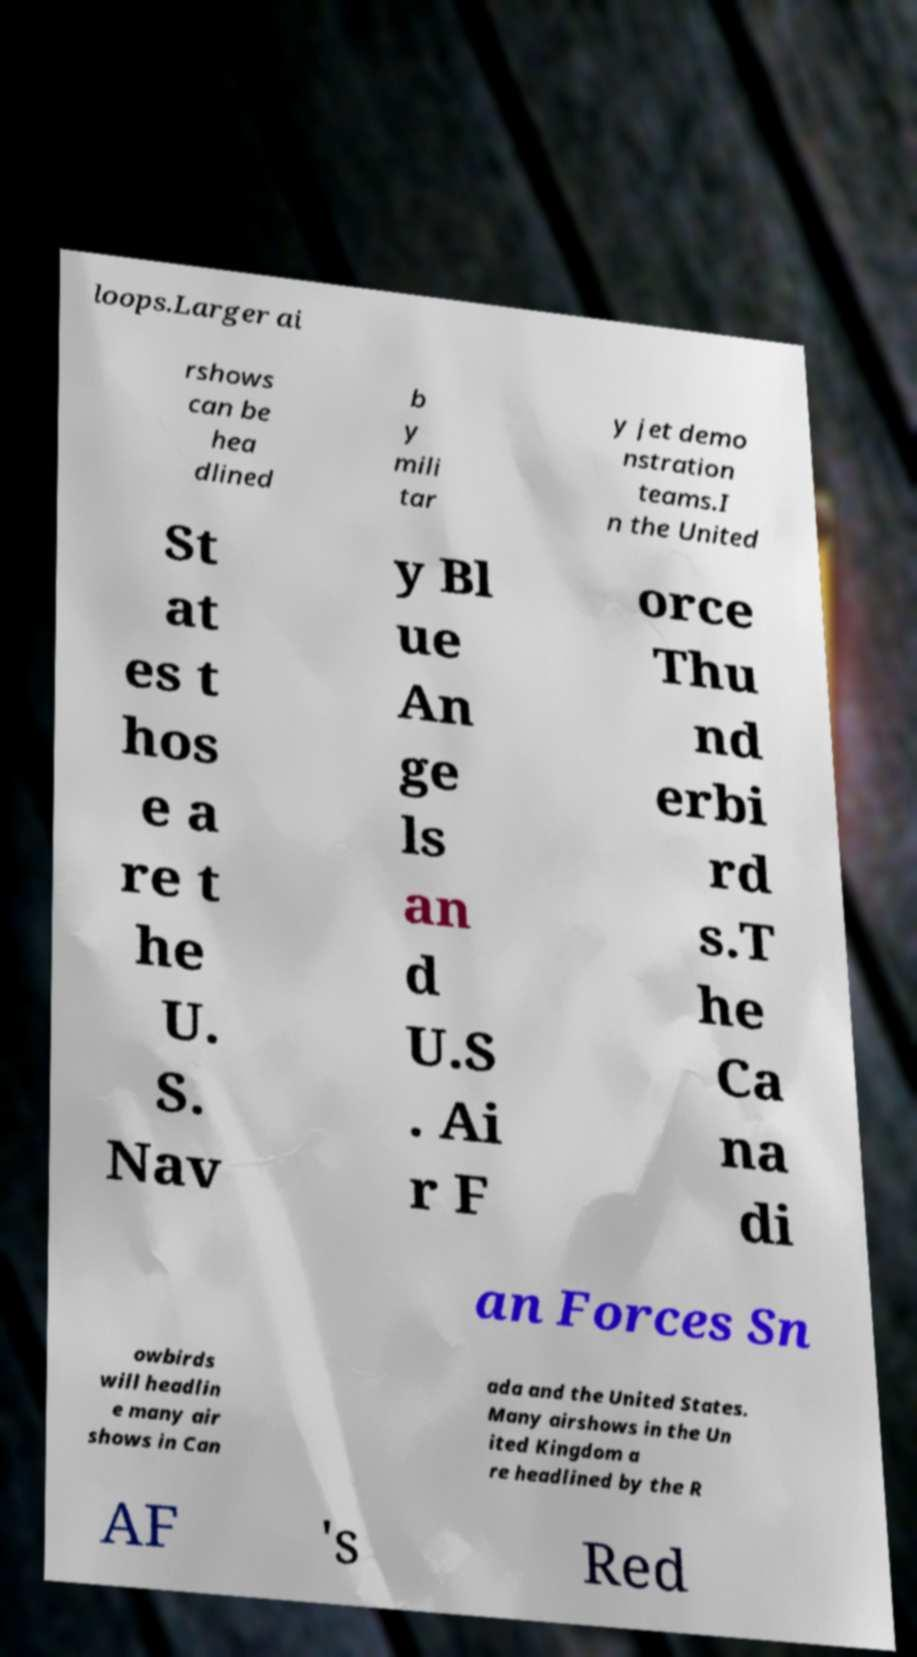Please identify and transcribe the text found in this image. loops.Larger ai rshows can be hea dlined b y mili tar y jet demo nstration teams.I n the United St at es t hos e a re t he U. S. Nav y Bl ue An ge ls an d U.S . Ai r F orce Thu nd erbi rd s.T he Ca na di an Forces Sn owbirds will headlin e many air shows in Can ada and the United States. Many airshows in the Un ited Kingdom a re headlined by the R AF 's Red 